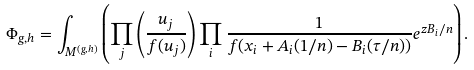<formula> <loc_0><loc_0><loc_500><loc_500>\Phi _ { g , h } = \int _ { M ^ { ( g , h ) } } \left ( \prod _ { j } \left ( \frac { u _ { j } } { f ( u _ { j } ) } \right ) \prod _ { i } \frac { 1 } { f ( x _ { i } + A _ { i } ( 1 / n ) - B _ { i } ( \tau / n ) ) } e ^ { z B _ { i } / n } \right ) .</formula> 